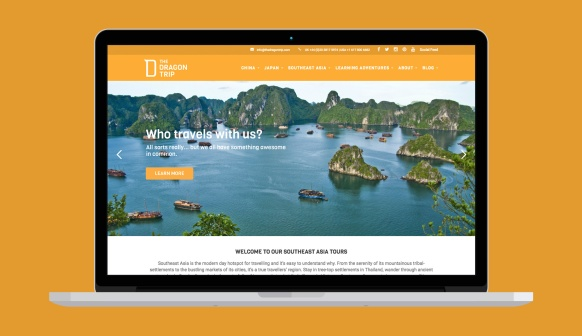Imagine a day visiting one of these islands. What specific activities could a traveler expect? A day visiting one of these islands might start with a sunrise hike up a scenic viewpoint, offering panoramic views of the sea and surrounding islands. After breakfast, travelers could set out on a guided tour exploring the island's hidden caves and historical sites. Midday might include a local cooking class where visitors learn to prepare traditional dishes before feasting on their creations. The afternoon could be spent kayaking through crystal-clear waters, exploring hidden lagoons, or lounging on pristine beaches. The evening might involve a beach bonfire, sharing stories under the starlit sky, and soaking in the tranquil vibes before retreating to their cozy beachside accommodations. 